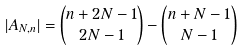Convert formula to latex. <formula><loc_0><loc_0><loc_500><loc_500>| A _ { N , n } | & = \begin{pmatrix} n + 2 N - 1 \\ 2 N - 1 \end{pmatrix} - \begin{pmatrix} n + N - 1 \\ N - 1 \end{pmatrix} \\</formula> 